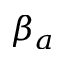<formula> <loc_0><loc_0><loc_500><loc_500>\beta _ { a }</formula> 